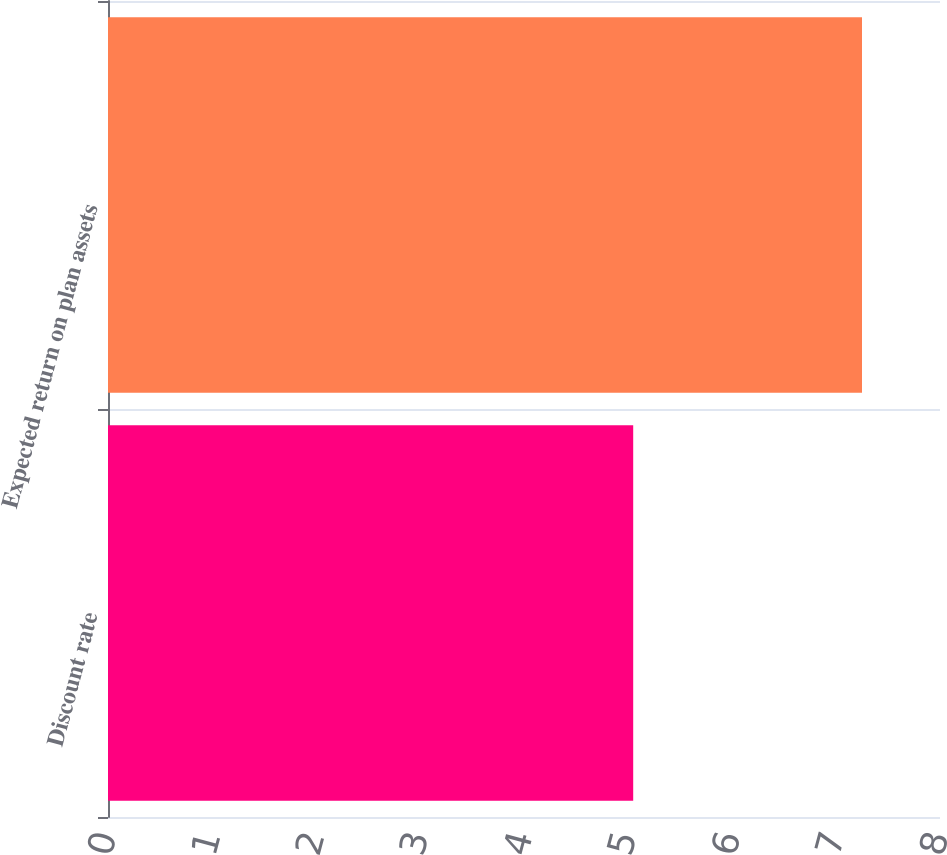Convert chart to OTSL. <chart><loc_0><loc_0><loc_500><loc_500><bar_chart><fcel>Discount rate<fcel>Expected return on plan assets<nl><fcel>5.05<fcel>7.25<nl></chart> 